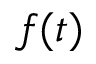<formula> <loc_0><loc_0><loc_500><loc_500>f ( t )</formula> 